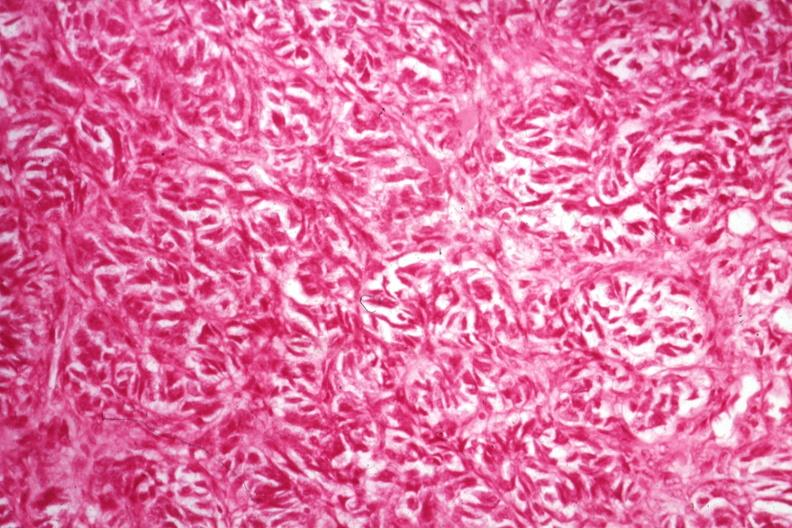s rheumatoid arthritis present?
Answer the question using a single word or phrase. No 